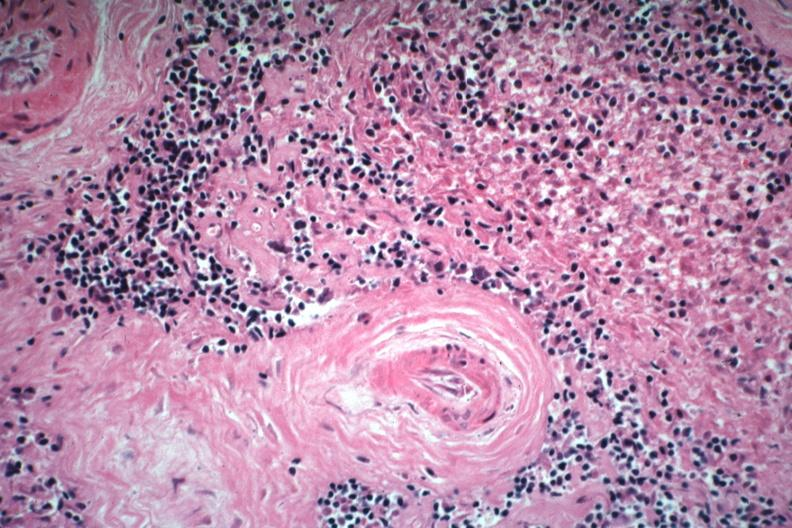s spleen present?
Answer the question using a single word or phrase. Yes 